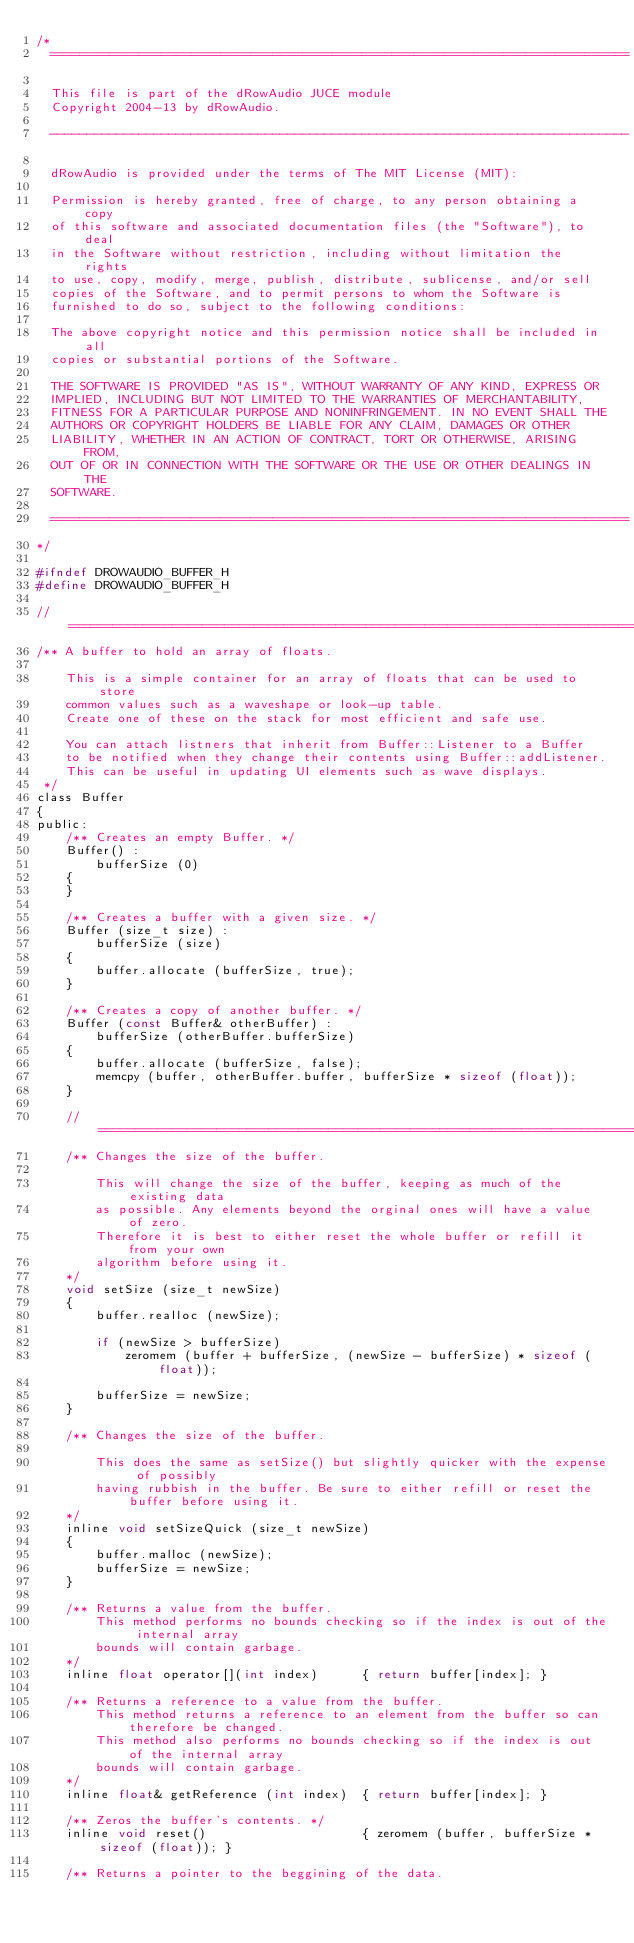Convert code to text. <code><loc_0><loc_0><loc_500><loc_500><_C_>/*
  ==============================================================================

  This file is part of the dRowAudio JUCE module
  Copyright 2004-13 by dRowAudio.

  ------------------------------------------------------------------------------

  dRowAudio is provided under the terms of The MIT License (MIT):

  Permission is hereby granted, free of charge, to any person obtaining a copy
  of this software and associated documentation files (the "Software"), to deal
  in the Software without restriction, including without limitation the rights
  to use, copy, modify, merge, publish, distribute, sublicense, and/or sell
  copies of the Software, and to permit persons to whom the Software is
  furnished to do so, subject to the following conditions:

  The above copyright notice and this permission notice shall be included in all
  copies or substantial portions of the Software.

  THE SOFTWARE IS PROVIDED "AS IS", WITHOUT WARRANTY OF ANY KIND, EXPRESS OR
  IMPLIED, INCLUDING BUT NOT LIMITED TO THE WARRANTIES OF MERCHANTABILITY,
  FITNESS FOR A PARTICULAR PURPOSE AND NONINFRINGEMENT. IN NO EVENT SHALL THE
  AUTHORS OR COPYRIGHT HOLDERS BE LIABLE FOR ANY CLAIM, DAMAGES OR OTHER
  LIABILITY, WHETHER IN AN ACTION OF CONTRACT, TORT OR OTHERWISE, ARISING FROM,
  OUT OF OR IN CONNECTION WITH THE SOFTWARE OR THE USE OR OTHER DEALINGS IN THE
  SOFTWARE.

  ==============================================================================
*/

#ifndef DROWAUDIO_BUFFER_H
#define DROWAUDIO_BUFFER_H

//==============================================================================
/** A buffer to hold an array of floats.

    This is a simple container for an array of floats that can be used to store
    common values such as a waveshape or look-up table.
    Create one of these on the stack for most efficient and safe use.

    You can attach listners that inherit from Buffer::Listener to a Buffer
    to be notified when they change their contents using Buffer::addListener.
    This can be useful in updating UI elements such as wave displays.
 */
class Buffer
{
public:
    /** Creates an empty Buffer. */
    Buffer() :
        bufferSize (0)
    {
    }

    /** Creates a buffer with a given size. */
    Buffer (size_t size) :
        bufferSize (size)
    {
        buffer.allocate (bufferSize, true);
    }

    /** Creates a copy of another buffer. */
    Buffer (const Buffer& otherBuffer) :
        bufferSize (otherBuffer.bufferSize)
    {
        buffer.allocate (bufferSize, false);
        memcpy (buffer, otherBuffer.buffer, bufferSize * sizeof (float));
    }

    //==============================================================================
    /** Changes the size of the buffer.

        This will change the size of the buffer, keeping as much of the existing data
        as possible. Any elements beyond the orginal ones will have a value of zero.
        Therefore it is best to either reset the whole buffer or refill it from your own
        algorithm before using it.
    */
    void setSize (size_t newSize)
    {
        buffer.realloc (newSize);

        if (newSize > bufferSize)
            zeromem (buffer + bufferSize, (newSize - bufferSize) * sizeof (float));

        bufferSize = newSize;
    }

    /** Changes the size of the buffer.

        This does the same as setSize() but slightly quicker with the expense of possibly
        having rubbish in the buffer. Be sure to either refill or reset the buffer before using it.
    */
    inline void setSizeQuick (size_t newSize)
    {
        buffer.malloc (newSize);
        bufferSize = newSize;
    }

    /** Returns a value from the buffer.
        This method performs no bounds checking so if the index is out of the internal array
        bounds will contain garbage.
    */
    inline float operator[](int index)      { return buffer[index]; }

    /** Returns a reference to a value from the buffer.
        This method returns a reference to an element from the buffer so can therefore be changed.
        This method also performs no bounds checking so if the index is out of the internal array
        bounds will contain garbage.
    */
    inline float& getReference (int index)  { return buffer[index]; }

    /** Zeros the buffer's contents. */
    inline void reset()                     { zeromem (buffer, bufferSize * sizeof (float)); }

    /** Returns a pointer to the beggining of the data.</code> 